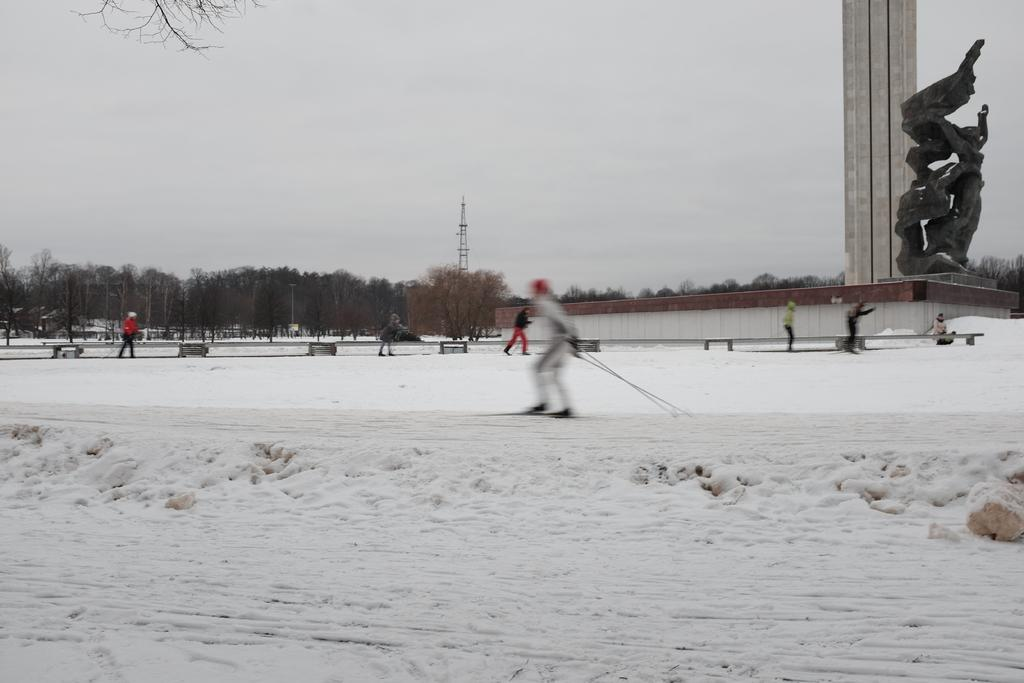What activity is the person in the image engaged in? There is a person skiing on the snow in the image. What type of natural environment is depicted in the image? There are trees in the image, which suggests a forest or wooded area. What structures can be seen in the image? There are poles and towers in the image. What additional feature is present in the image? There is a sculpture in the image. Are there any other people in the image? Yes, there are other persons in the image. What can be seen in the background of the image? The sky is visible in the background of the image. What type of jar is being used to point at the sky in the image? There is no jar or pointing gesture present in the image. 